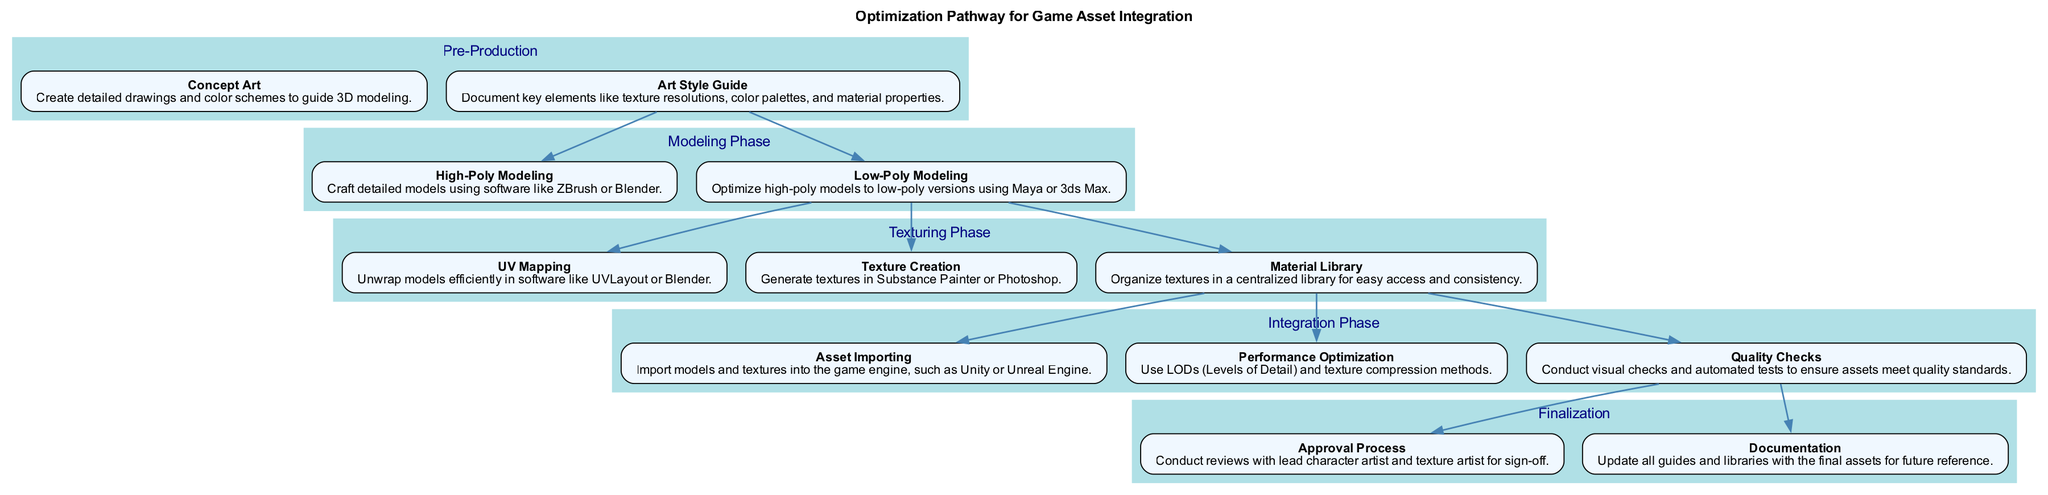What is the first phase in the optimization pathway? The diagram indicates that "Pre-Production" is the first phase listed at the top, establishing the starting point for the optimization process.
Answer: Pre-Production How many steps are there in the Texturing Phase? By reviewing the "Texturing Phase," the nodes indicate there are three distinct steps: UV Mapping, Texture Creation, and Material Library.
Answer: 3 What is the main purpose of the 'Quality Checks' step? The 'Quality Checks' step ensures that all assets meet established quality standards through visual checks and automated tests, which are crucial for maintaining quality throughout integration.
Answer: Ensure asset quality Which step follows 'Low-Poly Modeling'? The diagram flow shows that after 'Low-Poly Modeling' in the Modeling Phase, the next step is 'UV Mapping' in the Texturing Phase, thus indicating the sequential progression in this pathway.
Answer: UV Mapping How many phases are present in the diagram? Upon counting the distinct sections outlined in the diagram, it is evident that there are five phases: Pre-Production, Modeling Phase, Texturing Phase, Integration Phase, and Finalization.
Answer: 5 What is the last step in the Integration Phase? The last step displayed in the Integration Phase is 'Quality Checks,' which signifies the final inspection stage before proceeding to Finalization.
Answer: Quality Checks What relationship exists between 'Asset Importing' and 'Performance Optimization'? The diagram indicates a direct flow from 'Asset Importing' to 'Performance Optimization,' suggesting that importing assets precedes the optimization process in the Integration Phase.
Answer: Sequential relationship What type of checks are conducted in the 'Quality Checks' step? 'Quality Checks' are described as involving visual checks and automated tests, indicating a dual approach to assessing asset quality and ensuring they meet design standards.
Answer: Visual and automated tests How does the 'Documentation' step contribute to future projects? 'Documentation' updates all guides and libraries with final assets, creating a resource for future reference that facilitates consistency and efficiency in subsequent projects.
Answer: For future reference 